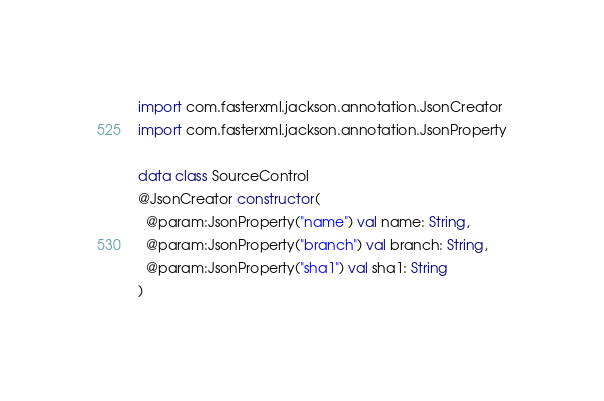<code> <loc_0><loc_0><loc_500><loc_500><_Kotlin_>
import com.fasterxml.jackson.annotation.JsonCreator
import com.fasterxml.jackson.annotation.JsonProperty

data class SourceControl
@JsonCreator constructor(
  @param:JsonProperty("name") val name: String,
  @param:JsonProperty("branch") val branch: String,
  @param:JsonProperty("sha1") val sha1: String
)
</code> 